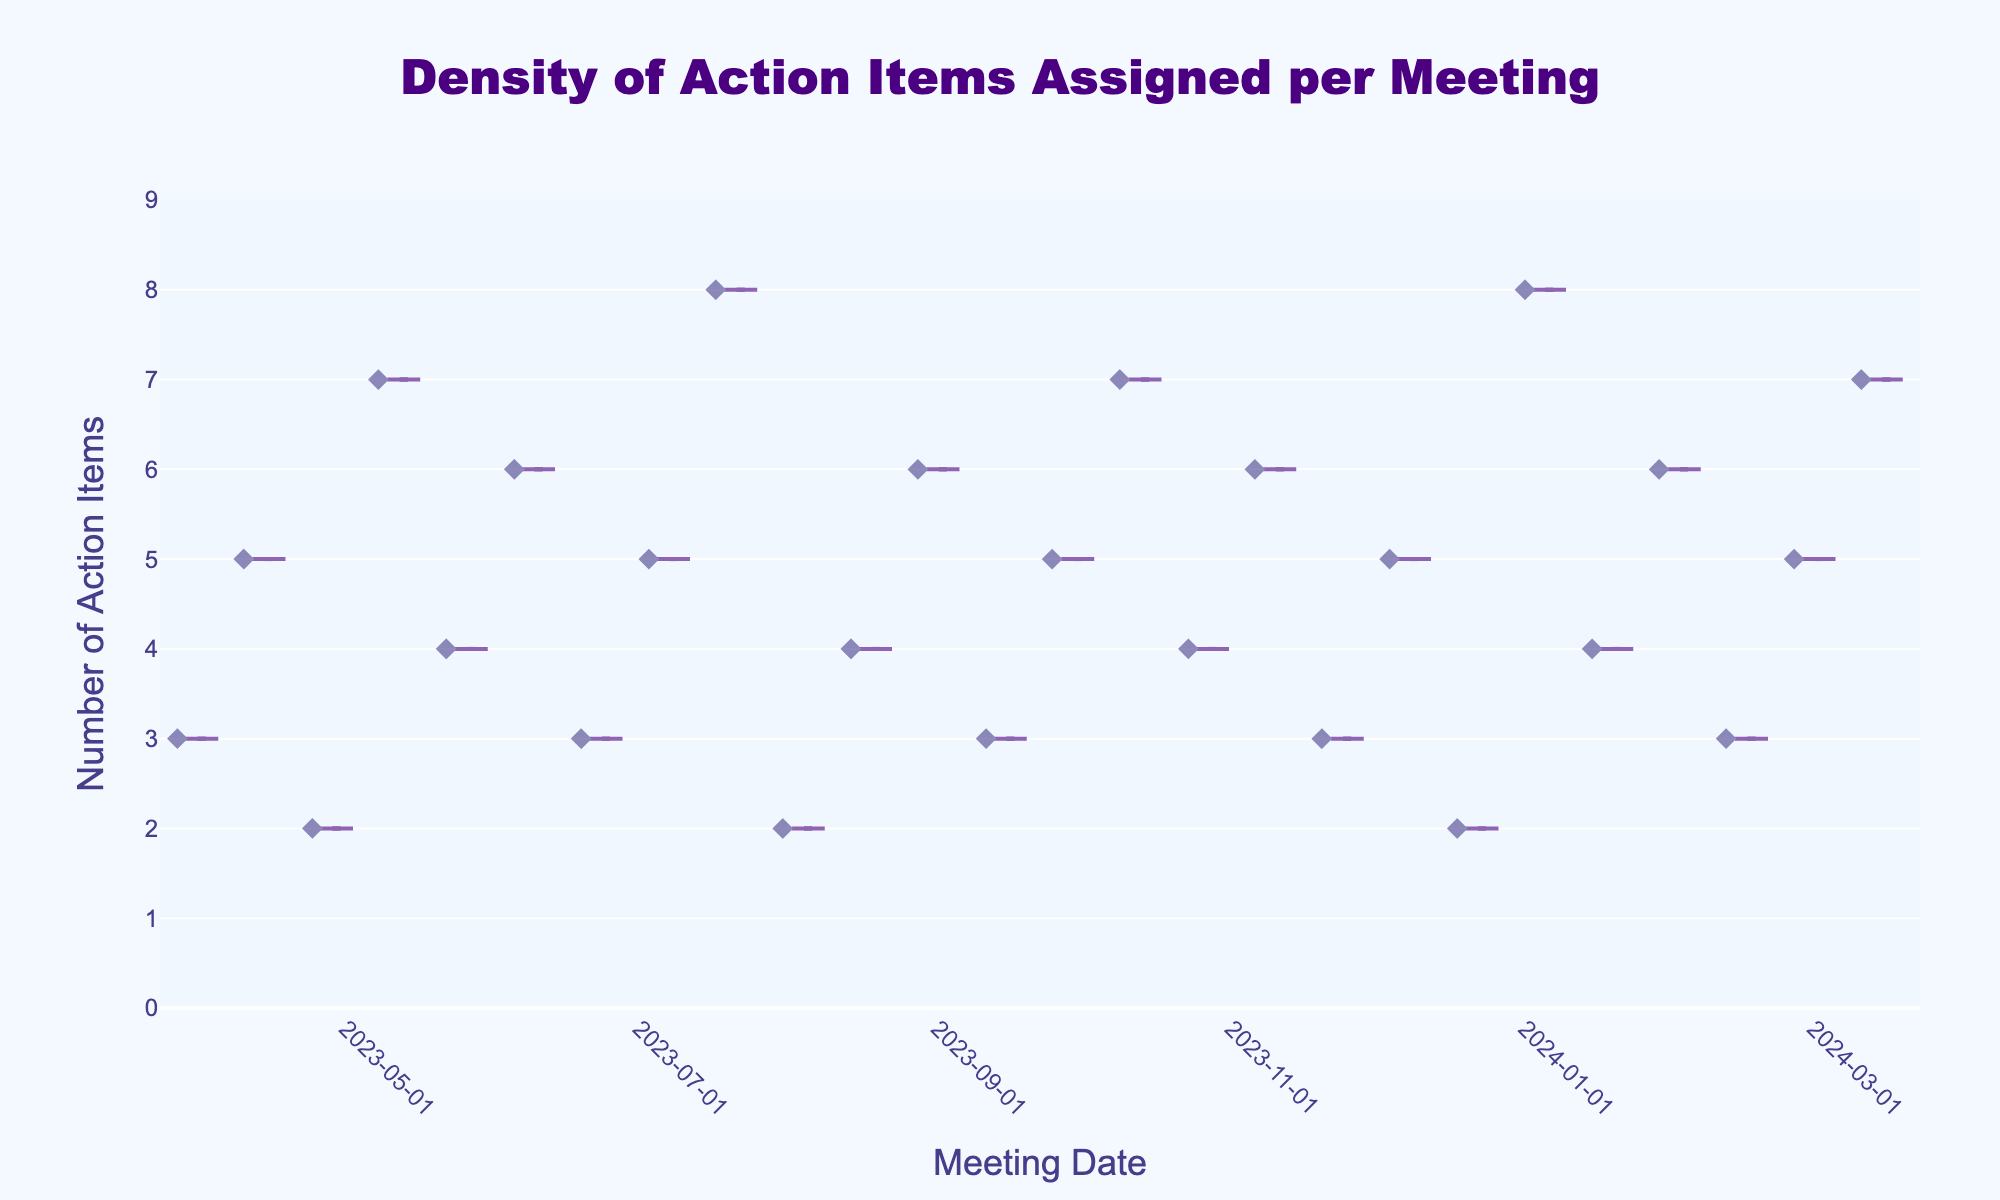When was the highest number of action items assigned in a single meeting? To identify the highest number of action items, observe the plot's y-axis and find the meeting date with the maximum y-value. From the plot, the highest value is 8 on January 6 and July 22, 2024.
Answer: January 6 and July 22, 2024 What is the range of the number of action items assigned per meeting? The range is the difference between the maximum and minimum values on the y-axis. The highest is 8 and the lowest is 2. So, 8 - 2 is 6.
Answer: 6 What was the average number of action items assigned per meeting? Average is calculated by summing all action items and dividing by the number of meetings. The sum is (3+5+2+7+4+6+3+5+8+2+4+6+3+5+7+4+6+3+5+2+8+4+6+3+5+7) = 118. There are 26 meetings. So, 118/26 ≈ 4.54.
Answer: 4.54 Which month had the highest average number of assigned action items? To find the month with the highest average, first group the data by month, then calculate the average for each. October has 2 meetings with values (7, 4), averaging (7+4)/2 = 5.5. December and other months have lower or equal averages.
Answer: October Are there any visible trends in the density of action items over the year? Trends can be observed by looking at the distribution and noticing patterns. There is a moderate fluctuation with multiple peaks in April, July, October, and January. The density increases notably around these months.
Answer: Moderate fluctuation with peaks Which meeting dates had exactly three action items assigned? To get this, look for the points intersecting the y-value of 3. The corresponding dates are April 1, June 24, September 16, November 25, and February 17.
Answer: April 1, June 24, September 16, November 25, February 17 Which dates had the lowest number of action items assigned? Identify points on the density plot at the minimum y-value, which is 2. These dates are April 29, August 5, December 23.
Answer: April 29, August 5, December 23 How many times were more than five action items assigned in a single meeting? Count the points above the y-value of 5. These points are June 10, July 22, September 2, October 14, November 11, January 6, February 3, March 2, March 16. There are 9 such occurrences.
Answer: 9 What months had the most fluctuating number of assigned action items? Look for months with the widest spread of points on the plot. April, June, and September show a wide range/measured by spread in the y-axis values.
Answer: April, June, September 